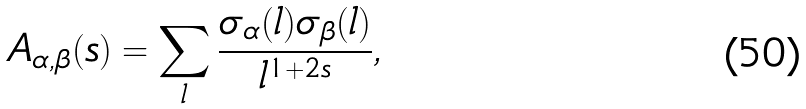<formula> <loc_0><loc_0><loc_500><loc_500>A _ { \alpha , \beta } ( s ) = \sum _ { l } \frac { \sigma _ { \alpha } ( l ) \sigma _ { \beta } ( l ) } { l ^ { 1 + 2 s } } ,</formula> 